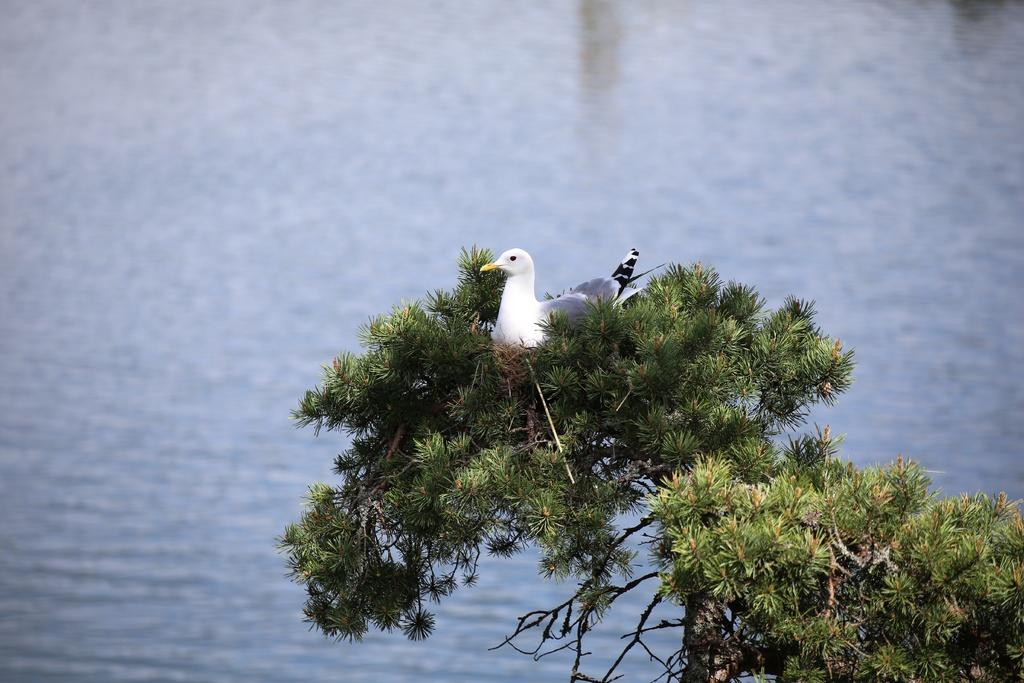What type of animal can be seen in the image? There is a bird in the image. Where is the bird located? The bird is on a tree. What else can be seen in the image besides the bird? There is water visible in the image. What book is the bird reading in the image? There is no book or reading activity present in the image; it features a bird on a tree with water visible in the background. 